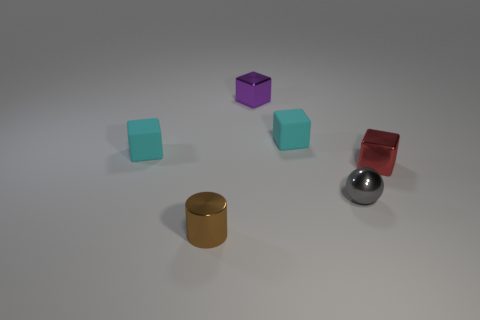Subtract all small red metallic cubes. How many cubes are left? 3 Add 3 red rubber objects. How many objects exist? 9 Subtract all red cubes. How many cubes are left? 3 Subtract all balls. How many objects are left? 5 Subtract 1 cylinders. How many cylinders are left? 0 Subtract all purple cubes. Subtract all purple balls. How many cubes are left? 3 Subtract all yellow blocks. How many yellow balls are left? 0 Subtract all gray metal spheres. Subtract all small metallic things. How many objects are left? 1 Add 6 small metal objects. How many small metal objects are left? 10 Add 5 tiny brown cylinders. How many tiny brown cylinders exist? 6 